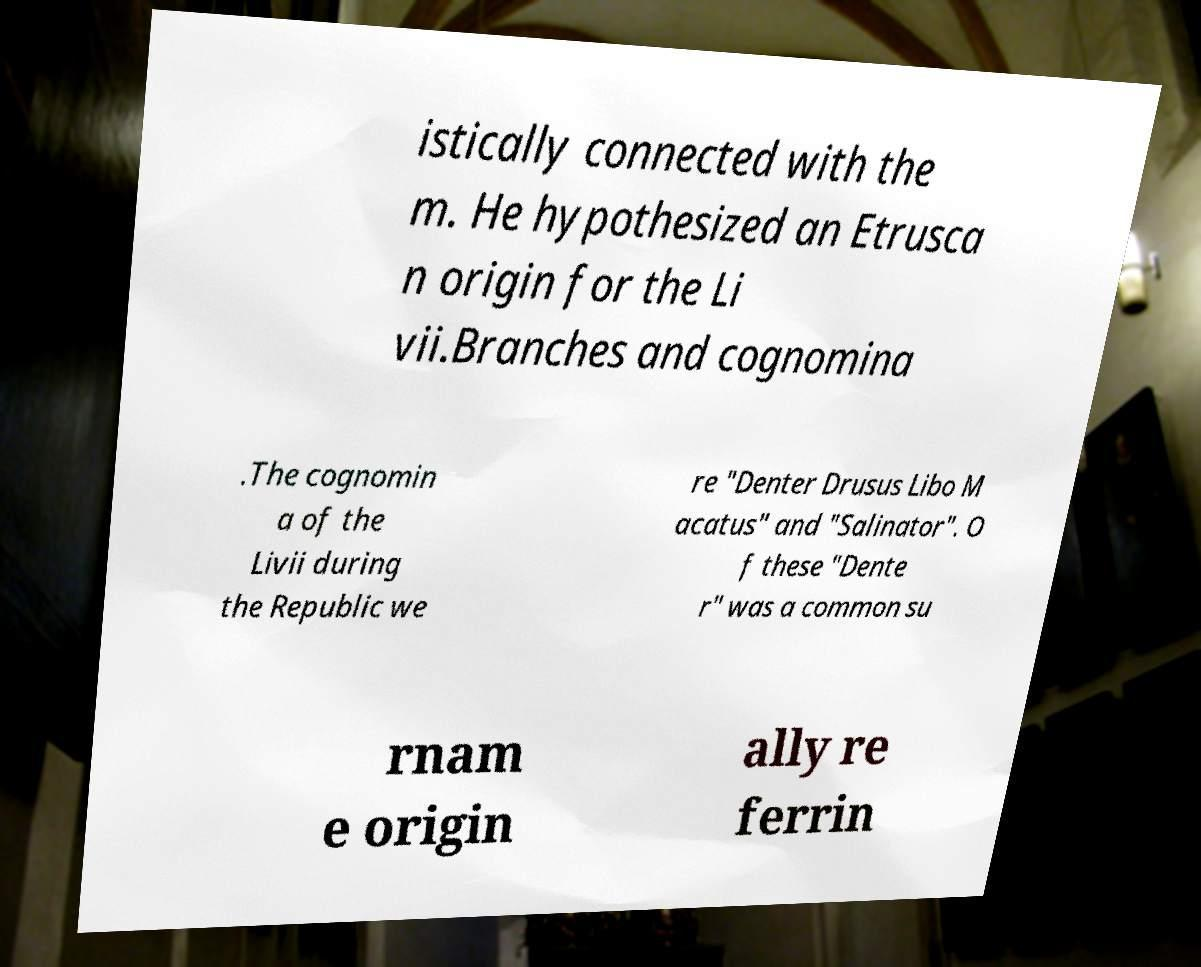Please read and relay the text visible in this image. What does it say? istically connected with the m. He hypothesized an Etrusca n origin for the Li vii.Branches and cognomina .The cognomin a of the Livii during the Republic we re "Denter Drusus Libo M acatus" and "Salinator". O f these "Dente r" was a common su rnam e origin ally re ferrin 